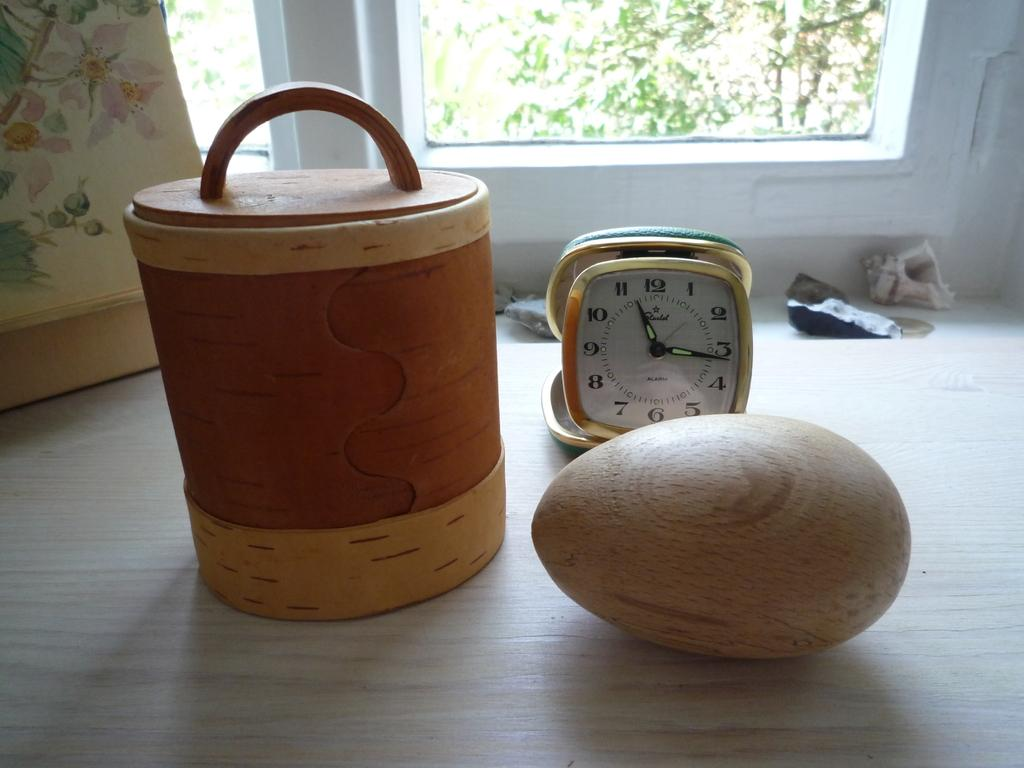<image>
Offer a succinct explanation of the picture presented. A table with a wooden football, a clock that is set at 11:15, and a basket on a table next to each other. 